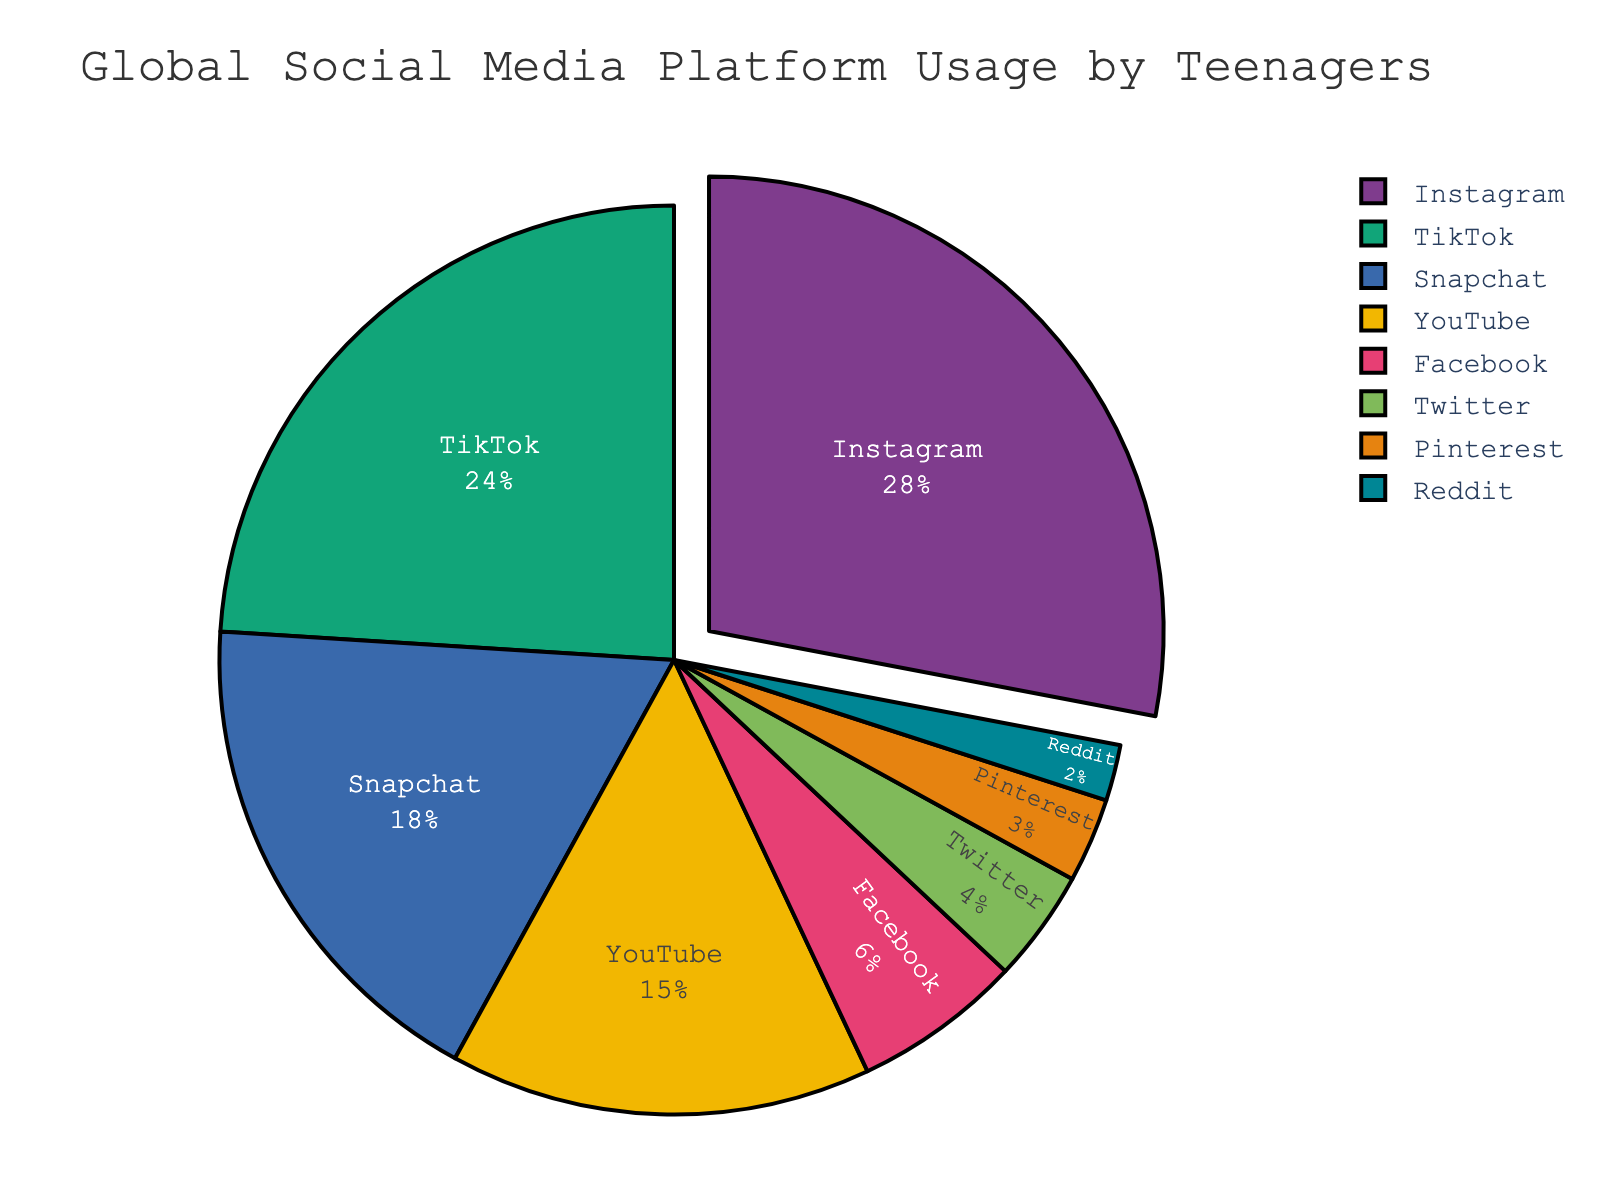Which platform has the highest percentage of usage by teenagers? The platform with the highest percentage will appear as the largest slice in the pie chart. By observation, Instagram has the largest slice.
Answer: Instagram Which platform has the least usage among teenagers? The platform with the smallest percentage will have the smallest slice in the pie chart. By observation, Reddit has the smallest slice.
Answer: Reddit What is the combined percentage of usage for Instagram and TikTok? To find the combined percentage, add the percentages for Instagram (28%) and TikTok (24%) from the pie chart. 28 + 24 = 52
Answer: 52 Is YouTube usage greater than Snapchat usage? Compare the sizes of the slices for YouTube and Snapchat. The chart shows Snapchat with 18% and YouTube with 15%; thus, Snapchat has a greater usage.
Answer: No What is the difference in percentage between Facebook and Twitter usage? Subtract the percentage of Twitter from Facebook. From the chart: 6% - 4% = 2%
Answer: 2 Which platform's usage is closest to the average percentage usage? First calculate the average percentage usage: (28 + 24 + 18 + 15 + 6 + 4 + 3 + 2) / 8 = 12.5. Then, identify the platform with the percentage closest to 12.5%. The closest platform to 12.5% is Facebook at 6%.
Answer: Facebook What is the combined percentage of less popular platforms (Facebook, Twitter, Pinterest, Reddit)? Add the percentages of Facebook (6%), Twitter (4%), Pinterest (3%), and Reddit (2%). 6 + 4 + 3 + 2 = 15%
Answer: 15 If you pull out the slice of the platform with the highest usage, how many slices remain? Since there are 8 platforms and we pull out the slice with the highest usage (Instagram), there will be 8 - 1 = 7 slices remaining.
Answer: 7 Which platforms have a combined usage percentage higher than Snapchat? Snapchat has 18%. Summing up the larger slices: Instagram (28%), TikTok (24%), YouTube (15%). Instagram alone is higher, and combining TikTok and YouTube's slices gives: 24 + 15 = 39, which is also higher than 18%. Thus, Instagram, and the combination of TikTok and YouTube.
Answer: Instagram, TikTok + YouTube 